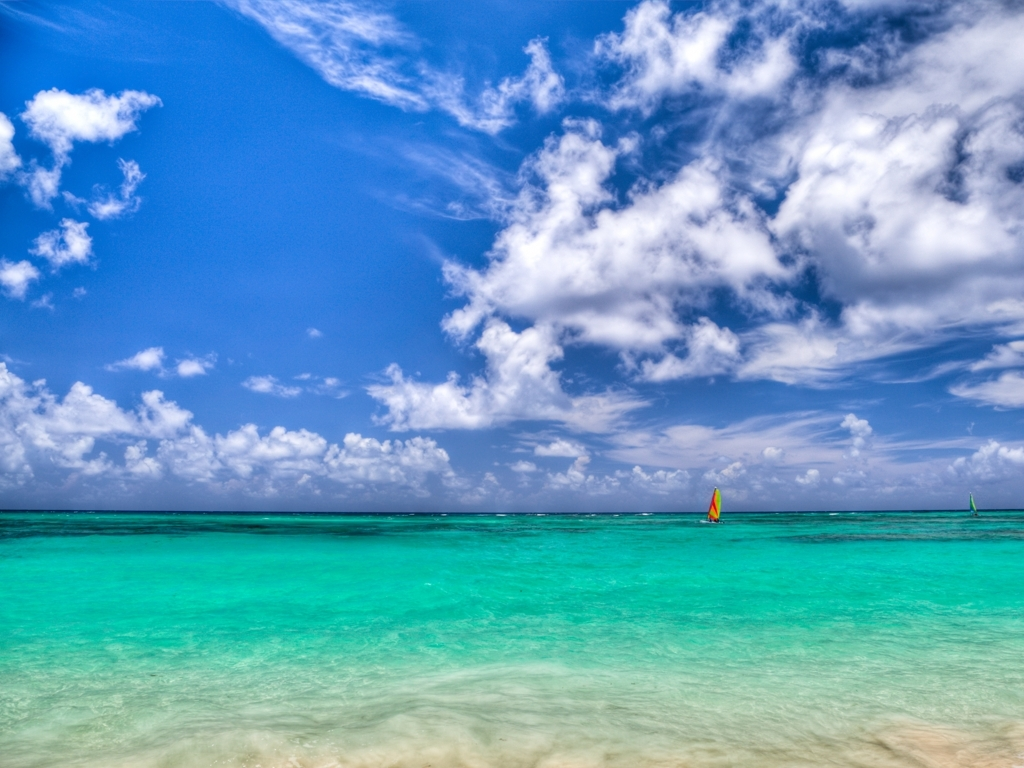What time of day does this image represent and how can you tell? It seems to be midday, as indicated by the high position of the sun, the brightness of the light, and the minimal length of the shadows cast on the beach. The vibrancy of the colors suggests the sun is near its zenith, bathing the landscape in strong, even light. Is there anything in this image that could help determine the location? Although there are no definitive landmarks to pinpoint the exact location, the combination of white sandy beach, clear turquoise water, and sailboats might suggest a tropical or subtropical climate, potentially in regions like the Caribbean, the Mediterranean, or the South Pacific. 